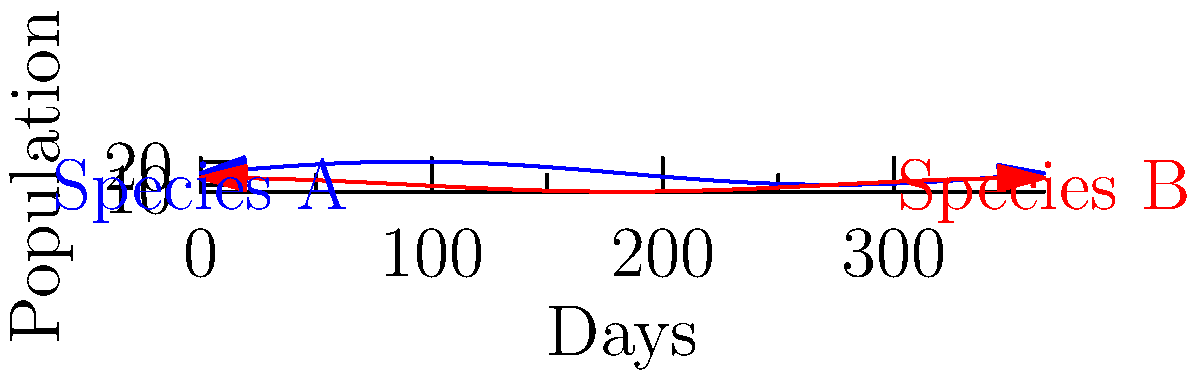In a fictional ecosystem, the populations of two interdependent species fluctuate seasonally. Species A's population is modeled by the function $f(x) = 5\sin(\frac{2\pi x}{365}) + 15$, while Species B's population is modeled by $g(x) = 3\cos(\frac{2\pi x}{365}) + 10$, where $x$ represents the day of the year. On which day of the year is the difference between the two species' populations at its maximum, and what is this maximum difference? To solve this problem, we need to follow these steps:

1) The difference between the two populations is given by:
   $h(x) = f(x) - g(x) = 5\sin(\frac{2\pi x}{365}) + 15 - [3\cos(\frac{2\pi x}{365}) + 10]$
   $h(x) = 5\sin(\frac{2\pi x}{365}) - 3\cos(\frac{2\pi x}{365}) + 5$

2) To find the maximum difference, we need to find where $h'(x) = 0$:
   $h'(x) = \frac{10\pi}{365}\cos(\frac{2\pi x}{365}) + \frac{6\pi}{365}\sin(\frac{2\pi x}{365})$

3) Setting $h'(x) = 0$:
   $\frac{10\pi}{365}\cos(\frac{2\pi x}{365}) + \frac{6\pi}{365}\sin(\frac{2\pi x}{365}) = 0$
   $5\cos(\frac{2\pi x}{365}) = -3\sin(\frac{2\pi x}{365})$
   $\tan(\frac{2\pi x}{365}) = -\frac{5}{3}$

4) Solving this equation:
   $\frac{2\pi x}{365} = \arctan(-\frac{5}{3}) + \pi = 2.55$ (we add $\pi$ because $\tan$ is negative)
   $x \approx 148.2$

5) The maximum difference occurs on day 148 (rounded to the nearest whole day).

6) To find the maximum difference, we substitute this value back into $h(x)$:
   $h(148) \approx 5\sin(\frac{2\pi \cdot 148}{365}) - 3\cos(\frac{2\pi \cdot 148}{365}) + 5 \approx 11.85$

Therefore, the maximum difference between the two populations is approximately 11.85, occurring on day 148 of the year.
Answer: Day 148, 11.85 